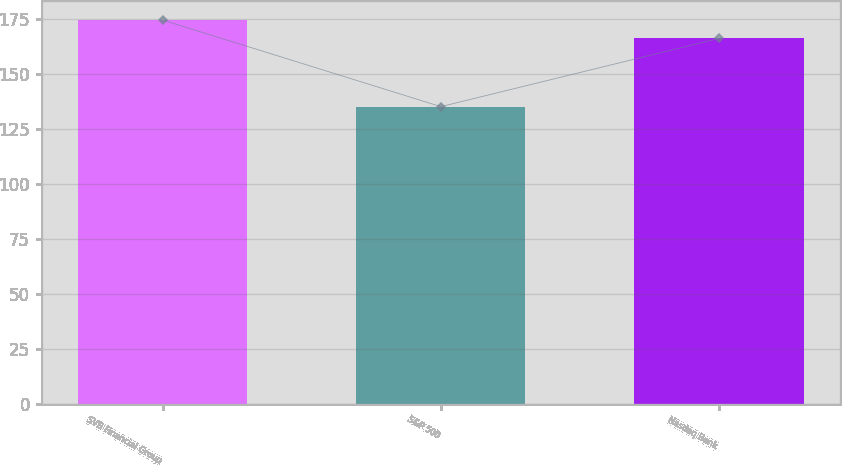Convert chart. <chart><loc_0><loc_0><loc_500><loc_500><bar_chart><fcel>SVB Financial Group<fcel>S&P 500<fcel>Nasdaq Bank<nl><fcel>174.41<fcel>135.03<fcel>166.05<nl></chart> 